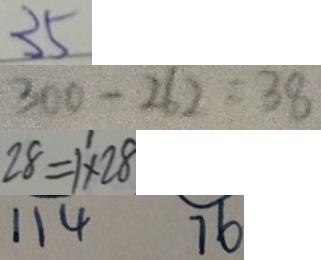Convert formula to latex. <formula><loc_0><loc_0><loc_500><loc_500>3 5 
 3 0 0 - 2 6 0 = 3 8 
 2 8 = 1 ^ { \prime } \times 2 8 
 1 1 4 7 6</formula> 